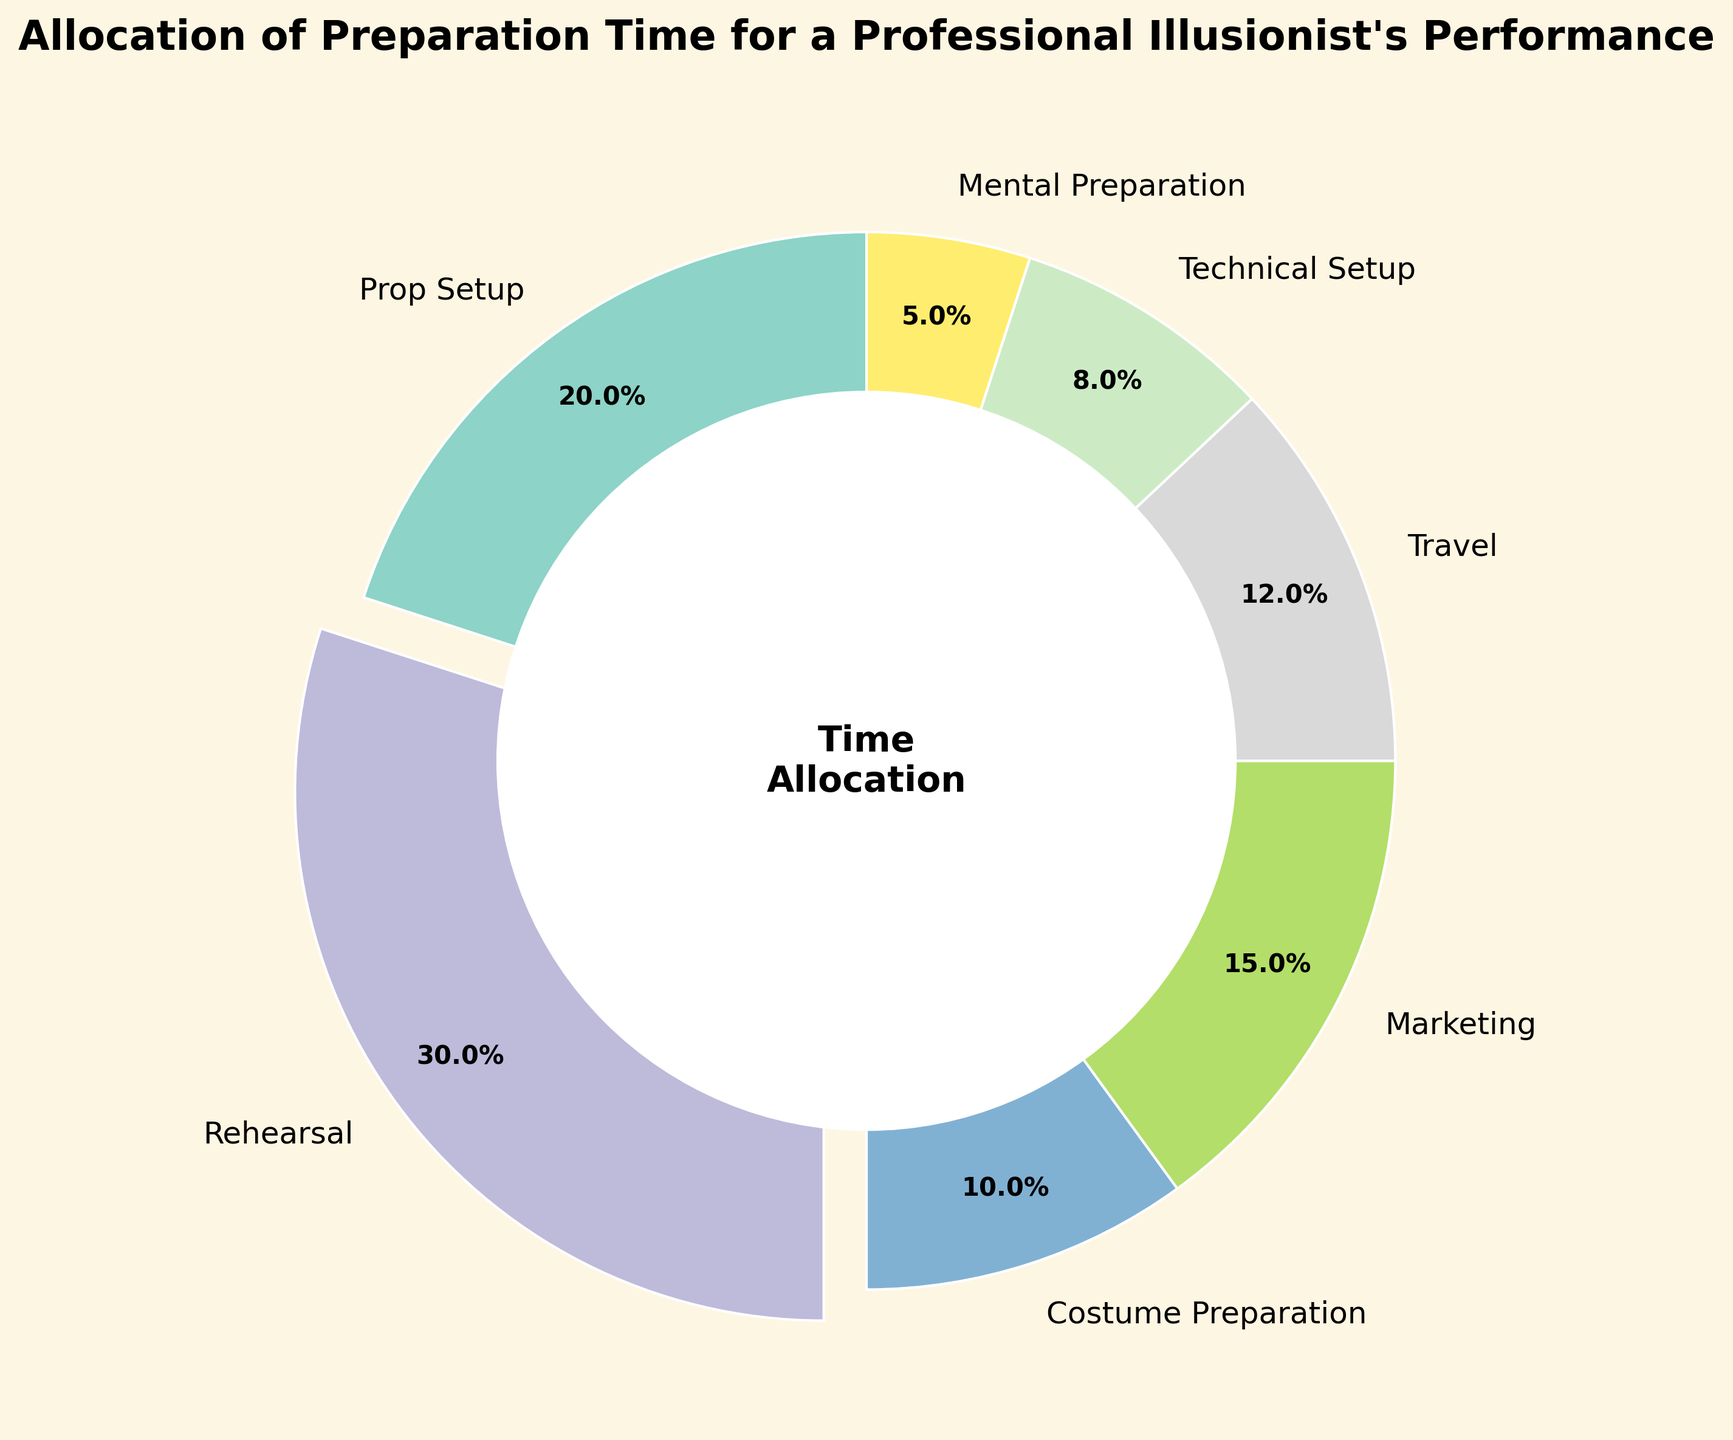Which category allocates the highest percentage of preparation time? By looking at the pie chart, the segment that is exploded (pulled out from the chart) represents the category with the highest percentage. This segment is labeled "Rehearsal," which accounts for 30%.
Answer: Rehearsal What is the combined percentage of time spent on Prop Setup and Costume Preparation? To find this, add the percentages of the segments labeled "Prop Setup" and "Costume Preparation." Prop Setup has 20% and Costume Preparation has 10%, making the combined percentage 20% + 10% = 30%.
Answer: 30% Which two categories collectively take up less than 10% of the total preparation time? By inspecting the pie chart, look for segments with the smallest percentages. "Mental Preparation" has 5%, and "Technical Setup" has 8%. Adding them, 5% + 8% = 13%, which does not meet the criterion. "Mental Preparation" alone at 5% is the only candidate as no other single category has less than 5%. Thus, no pair fulfills this criterion.
Answer: None What is the difference in percentage points between Marketing and Travel? Identify the segments labeled "Marketing" and "Travel." Marketing accounts for 15% and Travel accounts for 12%. Subtract the smaller percentage from the larger one: 15% - 12% = 3%.
Answer: 3% How many categories have a percentage allocation greater than 15%? Examine the pie chart for all segments with percentages higher than 15%. Only "Rehearsal" with 30% exceeds 15%.
Answer: 1 What is the average percentage allocation of Marketing, Travel, and Technical Setup? Add the percentages of these three categories: 15% (Marketing) + 12% (Travel) + 8% (Technical Setup). Sum = 35%. Divide the sum by the number of categories (3): 35% / 3 ≈ 11.67%.
Answer: 11.67% Which category uses a pinkish segment in the chart? By visually inspecting the pie chart, the pinkish color typically corresponds to the "Marketing" category.
Answer: Marketing What is the sum percentage of the three least time-consuming categories? The percentages for Mental Preparation (5%), Technical Setup (8%), and Costume Preparation (10%) are the lowest. Sum them: 5% + 8% + 10% = 23%.
Answer: 23% Which category occupies an orange segment in the pie chart? Visually identify the orange segment in the pie chart, which commonly corresponds to "Prop Setup" or can be confirmed by context; for this chart, assume "Prop Setup."
Answer: Prop Setup 